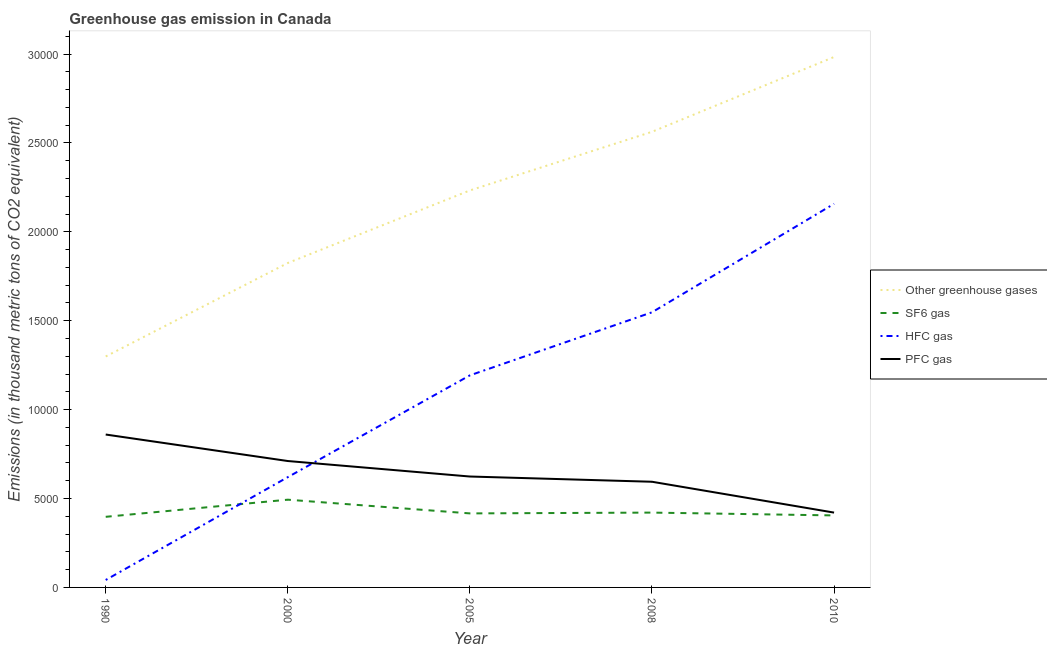What is the emission of greenhouse gases in 2008?
Give a very brief answer. 2.56e+04. Across all years, what is the maximum emission of greenhouse gases?
Give a very brief answer. 2.98e+04. Across all years, what is the minimum emission of hfc gas?
Your response must be concise. 418.5. What is the total emission of hfc gas in the graph?
Offer a very short reply. 5.56e+04. What is the difference between the emission of hfc gas in 1990 and that in 2005?
Make the answer very short. -1.15e+04. What is the difference between the emission of greenhouse gases in 2000 and the emission of sf6 gas in 2008?
Make the answer very short. 1.40e+04. What is the average emission of pfc gas per year?
Your response must be concise. 6420.18. In the year 1990, what is the difference between the emission of pfc gas and emission of sf6 gas?
Provide a short and direct response. 4628.5. What is the ratio of the emission of pfc gas in 1990 to that in 2005?
Offer a very short reply. 1.38. What is the difference between the highest and the second highest emission of sf6 gas?
Ensure brevity in your answer.  726.3. What is the difference between the highest and the lowest emission of sf6 gas?
Offer a terse response. 963.3. In how many years, is the emission of pfc gas greater than the average emission of pfc gas taken over all years?
Provide a succinct answer. 2. Is the sum of the emission of hfc gas in 2008 and 2010 greater than the maximum emission of greenhouse gases across all years?
Keep it short and to the point. Yes. Is it the case that in every year, the sum of the emission of pfc gas and emission of sf6 gas is greater than the sum of emission of hfc gas and emission of greenhouse gases?
Your answer should be very brief. Yes. Does the emission of hfc gas monotonically increase over the years?
Offer a very short reply. Yes. Is the emission of hfc gas strictly greater than the emission of sf6 gas over the years?
Ensure brevity in your answer.  No. Is the emission of pfc gas strictly less than the emission of hfc gas over the years?
Keep it short and to the point. No. How many lines are there?
Keep it short and to the point. 4. What is the difference between two consecutive major ticks on the Y-axis?
Your answer should be very brief. 5000. Are the values on the major ticks of Y-axis written in scientific E-notation?
Your answer should be very brief. No. Does the graph contain grids?
Give a very brief answer. No. Where does the legend appear in the graph?
Provide a short and direct response. Center right. What is the title of the graph?
Provide a succinct answer. Greenhouse gas emission in Canada. Does "Tracking ability" appear as one of the legend labels in the graph?
Your answer should be very brief. No. What is the label or title of the Y-axis?
Ensure brevity in your answer.  Emissions (in thousand metric tons of CO2 equivalent). What is the Emissions (in thousand metric tons of CO2 equivalent) of Other greenhouse gases in 1990?
Keep it short and to the point. 1.30e+04. What is the Emissions (in thousand metric tons of CO2 equivalent) of SF6 gas in 1990?
Give a very brief answer. 3971.8. What is the Emissions (in thousand metric tons of CO2 equivalent) of HFC gas in 1990?
Make the answer very short. 418.5. What is the Emissions (in thousand metric tons of CO2 equivalent) of PFC gas in 1990?
Ensure brevity in your answer.  8600.3. What is the Emissions (in thousand metric tons of CO2 equivalent) of Other greenhouse gases in 2000?
Make the answer very short. 1.82e+04. What is the Emissions (in thousand metric tons of CO2 equivalent) in SF6 gas in 2000?
Ensure brevity in your answer.  4935.1. What is the Emissions (in thousand metric tons of CO2 equivalent) in HFC gas in 2000?
Give a very brief answer. 6202.8. What is the Emissions (in thousand metric tons of CO2 equivalent) in PFC gas in 2000?
Offer a terse response. 7109.9. What is the Emissions (in thousand metric tons of CO2 equivalent) in Other greenhouse gases in 2005?
Keep it short and to the point. 2.23e+04. What is the Emissions (in thousand metric tons of CO2 equivalent) in SF6 gas in 2005?
Provide a short and direct response. 4163.8. What is the Emissions (in thousand metric tons of CO2 equivalent) of HFC gas in 2005?
Give a very brief answer. 1.19e+04. What is the Emissions (in thousand metric tons of CO2 equivalent) in PFC gas in 2005?
Ensure brevity in your answer.  6238. What is the Emissions (in thousand metric tons of CO2 equivalent) in Other greenhouse gases in 2008?
Offer a terse response. 2.56e+04. What is the Emissions (in thousand metric tons of CO2 equivalent) in SF6 gas in 2008?
Your answer should be very brief. 4208.8. What is the Emissions (in thousand metric tons of CO2 equivalent) of HFC gas in 2008?
Give a very brief answer. 1.55e+04. What is the Emissions (in thousand metric tons of CO2 equivalent) of PFC gas in 2008?
Offer a very short reply. 5943.7. What is the Emissions (in thousand metric tons of CO2 equivalent) in Other greenhouse gases in 2010?
Ensure brevity in your answer.  2.98e+04. What is the Emissions (in thousand metric tons of CO2 equivalent) in SF6 gas in 2010?
Give a very brief answer. 4050. What is the Emissions (in thousand metric tons of CO2 equivalent) in HFC gas in 2010?
Give a very brief answer. 2.16e+04. What is the Emissions (in thousand metric tons of CO2 equivalent) in PFC gas in 2010?
Your answer should be compact. 4209. Across all years, what is the maximum Emissions (in thousand metric tons of CO2 equivalent) in Other greenhouse gases?
Your response must be concise. 2.98e+04. Across all years, what is the maximum Emissions (in thousand metric tons of CO2 equivalent) of SF6 gas?
Offer a very short reply. 4935.1. Across all years, what is the maximum Emissions (in thousand metric tons of CO2 equivalent) in HFC gas?
Ensure brevity in your answer.  2.16e+04. Across all years, what is the maximum Emissions (in thousand metric tons of CO2 equivalent) in PFC gas?
Offer a very short reply. 8600.3. Across all years, what is the minimum Emissions (in thousand metric tons of CO2 equivalent) in Other greenhouse gases?
Provide a succinct answer. 1.30e+04. Across all years, what is the minimum Emissions (in thousand metric tons of CO2 equivalent) in SF6 gas?
Give a very brief answer. 3971.8. Across all years, what is the minimum Emissions (in thousand metric tons of CO2 equivalent) of HFC gas?
Make the answer very short. 418.5. Across all years, what is the minimum Emissions (in thousand metric tons of CO2 equivalent) of PFC gas?
Your answer should be compact. 4209. What is the total Emissions (in thousand metric tons of CO2 equivalent) of Other greenhouse gases in the graph?
Offer a very short reply. 1.09e+05. What is the total Emissions (in thousand metric tons of CO2 equivalent) in SF6 gas in the graph?
Make the answer very short. 2.13e+04. What is the total Emissions (in thousand metric tons of CO2 equivalent) in HFC gas in the graph?
Make the answer very short. 5.56e+04. What is the total Emissions (in thousand metric tons of CO2 equivalent) of PFC gas in the graph?
Your response must be concise. 3.21e+04. What is the difference between the Emissions (in thousand metric tons of CO2 equivalent) of Other greenhouse gases in 1990 and that in 2000?
Provide a succinct answer. -5257.2. What is the difference between the Emissions (in thousand metric tons of CO2 equivalent) of SF6 gas in 1990 and that in 2000?
Your answer should be compact. -963.3. What is the difference between the Emissions (in thousand metric tons of CO2 equivalent) of HFC gas in 1990 and that in 2000?
Your answer should be compact. -5784.3. What is the difference between the Emissions (in thousand metric tons of CO2 equivalent) of PFC gas in 1990 and that in 2000?
Your answer should be very brief. 1490.4. What is the difference between the Emissions (in thousand metric tons of CO2 equivalent) in Other greenhouse gases in 1990 and that in 2005?
Provide a succinct answer. -9339.6. What is the difference between the Emissions (in thousand metric tons of CO2 equivalent) in SF6 gas in 1990 and that in 2005?
Offer a very short reply. -192. What is the difference between the Emissions (in thousand metric tons of CO2 equivalent) in HFC gas in 1990 and that in 2005?
Keep it short and to the point. -1.15e+04. What is the difference between the Emissions (in thousand metric tons of CO2 equivalent) in PFC gas in 1990 and that in 2005?
Offer a terse response. 2362.3. What is the difference between the Emissions (in thousand metric tons of CO2 equivalent) in Other greenhouse gases in 1990 and that in 2008?
Offer a terse response. -1.26e+04. What is the difference between the Emissions (in thousand metric tons of CO2 equivalent) in SF6 gas in 1990 and that in 2008?
Make the answer very short. -237. What is the difference between the Emissions (in thousand metric tons of CO2 equivalent) in HFC gas in 1990 and that in 2008?
Give a very brief answer. -1.51e+04. What is the difference between the Emissions (in thousand metric tons of CO2 equivalent) of PFC gas in 1990 and that in 2008?
Your answer should be very brief. 2656.6. What is the difference between the Emissions (in thousand metric tons of CO2 equivalent) in Other greenhouse gases in 1990 and that in 2010?
Provide a short and direct response. -1.68e+04. What is the difference between the Emissions (in thousand metric tons of CO2 equivalent) of SF6 gas in 1990 and that in 2010?
Provide a succinct answer. -78.2. What is the difference between the Emissions (in thousand metric tons of CO2 equivalent) in HFC gas in 1990 and that in 2010?
Offer a terse response. -2.12e+04. What is the difference between the Emissions (in thousand metric tons of CO2 equivalent) of PFC gas in 1990 and that in 2010?
Your answer should be very brief. 4391.3. What is the difference between the Emissions (in thousand metric tons of CO2 equivalent) of Other greenhouse gases in 2000 and that in 2005?
Keep it short and to the point. -4082.4. What is the difference between the Emissions (in thousand metric tons of CO2 equivalent) of SF6 gas in 2000 and that in 2005?
Keep it short and to the point. 771.3. What is the difference between the Emissions (in thousand metric tons of CO2 equivalent) of HFC gas in 2000 and that in 2005?
Ensure brevity in your answer.  -5725.6. What is the difference between the Emissions (in thousand metric tons of CO2 equivalent) of PFC gas in 2000 and that in 2005?
Provide a short and direct response. 871.9. What is the difference between the Emissions (in thousand metric tons of CO2 equivalent) in Other greenhouse gases in 2000 and that in 2008?
Offer a terse response. -7379.5. What is the difference between the Emissions (in thousand metric tons of CO2 equivalent) of SF6 gas in 2000 and that in 2008?
Offer a terse response. 726.3. What is the difference between the Emissions (in thousand metric tons of CO2 equivalent) of HFC gas in 2000 and that in 2008?
Keep it short and to the point. -9272. What is the difference between the Emissions (in thousand metric tons of CO2 equivalent) in PFC gas in 2000 and that in 2008?
Offer a terse response. 1166.2. What is the difference between the Emissions (in thousand metric tons of CO2 equivalent) in Other greenhouse gases in 2000 and that in 2010?
Your answer should be very brief. -1.16e+04. What is the difference between the Emissions (in thousand metric tons of CO2 equivalent) in SF6 gas in 2000 and that in 2010?
Ensure brevity in your answer.  885.1. What is the difference between the Emissions (in thousand metric tons of CO2 equivalent) of HFC gas in 2000 and that in 2010?
Provide a short and direct response. -1.54e+04. What is the difference between the Emissions (in thousand metric tons of CO2 equivalent) of PFC gas in 2000 and that in 2010?
Your response must be concise. 2900.9. What is the difference between the Emissions (in thousand metric tons of CO2 equivalent) of Other greenhouse gases in 2005 and that in 2008?
Provide a short and direct response. -3297.1. What is the difference between the Emissions (in thousand metric tons of CO2 equivalent) in SF6 gas in 2005 and that in 2008?
Your answer should be very brief. -45. What is the difference between the Emissions (in thousand metric tons of CO2 equivalent) in HFC gas in 2005 and that in 2008?
Offer a terse response. -3546.4. What is the difference between the Emissions (in thousand metric tons of CO2 equivalent) of PFC gas in 2005 and that in 2008?
Provide a succinct answer. 294.3. What is the difference between the Emissions (in thousand metric tons of CO2 equivalent) of Other greenhouse gases in 2005 and that in 2010?
Give a very brief answer. -7505.8. What is the difference between the Emissions (in thousand metric tons of CO2 equivalent) in SF6 gas in 2005 and that in 2010?
Your answer should be very brief. 113.8. What is the difference between the Emissions (in thousand metric tons of CO2 equivalent) of HFC gas in 2005 and that in 2010?
Make the answer very short. -9648.6. What is the difference between the Emissions (in thousand metric tons of CO2 equivalent) in PFC gas in 2005 and that in 2010?
Make the answer very short. 2029. What is the difference between the Emissions (in thousand metric tons of CO2 equivalent) in Other greenhouse gases in 2008 and that in 2010?
Your answer should be very brief. -4208.7. What is the difference between the Emissions (in thousand metric tons of CO2 equivalent) in SF6 gas in 2008 and that in 2010?
Offer a terse response. 158.8. What is the difference between the Emissions (in thousand metric tons of CO2 equivalent) of HFC gas in 2008 and that in 2010?
Make the answer very short. -6102.2. What is the difference between the Emissions (in thousand metric tons of CO2 equivalent) of PFC gas in 2008 and that in 2010?
Give a very brief answer. 1734.7. What is the difference between the Emissions (in thousand metric tons of CO2 equivalent) in Other greenhouse gases in 1990 and the Emissions (in thousand metric tons of CO2 equivalent) in SF6 gas in 2000?
Your answer should be compact. 8055.5. What is the difference between the Emissions (in thousand metric tons of CO2 equivalent) in Other greenhouse gases in 1990 and the Emissions (in thousand metric tons of CO2 equivalent) in HFC gas in 2000?
Provide a short and direct response. 6787.8. What is the difference between the Emissions (in thousand metric tons of CO2 equivalent) of Other greenhouse gases in 1990 and the Emissions (in thousand metric tons of CO2 equivalent) of PFC gas in 2000?
Keep it short and to the point. 5880.7. What is the difference between the Emissions (in thousand metric tons of CO2 equivalent) of SF6 gas in 1990 and the Emissions (in thousand metric tons of CO2 equivalent) of HFC gas in 2000?
Your response must be concise. -2231. What is the difference between the Emissions (in thousand metric tons of CO2 equivalent) in SF6 gas in 1990 and the Emissions (in thousand metric tons of CO2 equivalent) in PFC gas in 2000?
Provide a succinct answer. -3138.1. What is the difference between the Emissions (in thousand metric tons of CO2 equivalent) of HFC gas in 1990 and the Emissions (in thousand metric tons of CO2 equivalent) of PFC gas in 2000?
Keep it short and to the point. -6691.4. What is the difference between the Emissions (in thousand metric tons of CO2 equivalent) of Other greenhouse gases in 1990 and the Emissions (in thousand metric tons of CO2 equivalent) of SF6 gas in 2005?
Provide a succinct answer. 8826.8. What is the difference between the Emissions (in thousand metric tons of CO2 equivalent) in Other greenhouse gases in 1990 and the Emissions (in thousand metric tons of CO2 equivalent) in HFC gas in 2005?
Offer a very short reply. 1062.2. What is the difference between the Emissions (in thousand metric tons of CO2 equivalent) in Other greenhouse gases in 1990 and the Emissions (in thousand metric tons of CO2 equivalent) in PFC gas in 2005?
Offer a very short reply. 6752.6. What is the difference between the Emissions (in thousand metric tons of CO2 equivalent) of SF6 gas in 1990 and the Emissions (in thousand metric tons of CO2 equivalent) of HFC gas in 2005?
Provide a succinct answer. -7956.6. What is the difference between the Emissions (in thousand metric tons of CO2 equivalent) in SF6 gas in 1990 and the Emissions (in thousand metric tons of CO2 equivalent) in PFC gas in 2005?
Make the answer very short. -2266.2. What is the difference between the Emissions (in thousand metric tons of CO2 equivalent) in HFC gas in 1990 and the Emissions (in thousand metric tons of CO2 equivalent) in PFC gas in 2005?
Provide a short and direct response. -5819.5. What is the difference between the Emissions (in thousand metric tons of CO2 equivalent) of Other greenhouse gases in 1990 and the Emissions (in thousand metric tons of CO2 equivalent) of SF6 gas in 2008?
Offer a terse response. 8781.8. What is the difference between the Emissions (in thousand metric tons of CO2 equivalent) in Other greenhouse gases in 1990 and the Emissions (in thousand metric tons of CO2 equivalent) in HFC gas in 2008?
Offer a terse response. -2484.2. What is the difference between the Emissions (in thousand metric tons of CO2 equivalent) in Other greenhouse gases in 1990 and the Emissions (in thousand metric tons of CO2 equivalent) in PFC gas in 2008?
Your answer should be compact. 7046.9. What is the difference between the Emissions (in thousand metric tons of CO2 equivalent) of SF6 gas in 1990 and the Emissions (in thousand metric tons of CO2 equivalent) of HFC gas in 2008?
Provide a short and direct response. -1.15e+04. What is the difference between the Emissions (in thousand metric tons of CO2 equivalent) of SF6 gas in 1990 and the Emissions (in thousand metric tons of CO2 equivalent) of PFC gas in 2008?
Provide a succinct answer. -1971.9. What is the difference between the Emissions (in thousand metric tons of CO2 equivalent) of HFC gas in 1990 and the Emissions (in thousand metric tons of CO2 equivalent) of PFC gas in 2008?
Give a very brief answer. -5525.2. What is the difference between the Emissions (in thousand metric tons of CO2 equivalent) in Other greenhouse gases in 1990 and the Emissions (in thousand metric tons of CO2 equivalent) in SF6 gas in 2010?
Give a very brief answer. 8940.6. What is the difference between the Emissions (in thousand metric tons of CO2 equivalent) in Other greenhouse gases in 1990 and the Emissions (in thousand metric tons of CO2 equivalent) in HFC gas in 2010?
Your answer should be very brief. -8586.4. What is the difference between the Emissions (in thousand metric tons of CO2 equivalent) in Other greenhouse gases in 1990 and the Emissions (in thousand metric tons of CO2 equivalent) in PFC gas in 2010?
Your answer should be very brief. 8781.6. What is the difference between the Emissions (in thousand metric tons of CO2 equivalent) in SF6 gas in 1990 and the Emissions (in thousand metric tons of CO2 equivalent) in HFC gas in 2010?
Your answer should be compact. -1.76e+04. What is the difference between the Emissions (in thousand metric tons of CO2 equivalent) of SF6 gas in 1990 and the Emissions (in thousand metric tons of CO2 equivalent) of PFC gas in 2010?
Offer a terse response. -237.2. What is the difference between the Emissions (in thousand metric tons of CO2 equivalent) of HFC gas in 1990 and the Emissions (in thousand metric tons of CO2 equivalent) of PFC gas in 2010?
Provide a short and direct response. -3790.5. What is the difference between the Emissions (in thousand metric tons of CO2 equivalent) of Other greenhouse gases in 2000 and the Emissions (in thousand metric tons of CO2 equivalent) of SF6 gas in 2005?
Offer a terse response. 1.41e+04. What is the difference between the Emissions (in thousand metric tons of CO2 equivalent) in Other greenhouse gases in 2000 and the Emissions (in thousand metric tons of CO2 equivalent) in HFC gas in 2005?
Ensure brevity in your answer.  6319.4. What is the difference between the Emissions (in thousand metric tons of CO2 equivalent) in Other greenhouse gases in 2000 and the Emissions (in thousand metric tons of CO2 equivalent) in PFC gas in 2005?
Your response must be concise. 1.20e+04. What is the difference between the Emissions (in thousand metric tons of CO2 equivalent) in SF6 gas in 2000 and the Emissions (in thousand metric tons of CO2 equivalent) in HFC gas in 2005?
Make the answer very short. -6993.3. What is the difference between the Emissions (in thousand metric tons of CO2 equivalent) in SF6 gas in 2000 and the Emissions (in thousand metric tons of CO2 equivalent) in PFC gas in 2005?
Your answer should be compact. -1302.9. What is the difference between the Emissions (in thousand metric tons of CO2 equivalent) of HFC gas in 2000 and the Emissions (in thousand metric tons of CO2 equivalent) of PFC gas in 2005?
Give a very brief answer. -35.2. What is the difference between the Emissions (in thousand metric tons of CO2 equivalent) of Other greenhouse gases in 2000 and the Emissions (in thousand metric tons of CO2 equivalent) of SF6 gas in 2008?
Make the answer very short. 1.40e+04. What is the difference between the Emissions (in thousand metric tons of CO2 equivalent) in Other greenhouse gases in 2000 and the Emissions (in thousand metric tons of CO2 equivalent) in HFC gas in 2008?
Your answer should be very brief. 2773. What is the difference between the Emissions (in thousand metric tons of CO2 equivalent) of Other greenhouse gases in 2000 and the Emissions (in thousand metric tons of CO2 equivalent) of PFC gas in 2008?
Make the answer very short. 1.23e+04. What is the difference between the Emissions (in thousand metric tons of CO2 equivalent) in SF6 gas in 2000 and the Emissions (in thousand metric tons of CO2 equivalent) in HFC gas in 2008?
Give a very brief answer. -1.05e+04. What is the difference between the Emissions (in thousand metric tons of CO2 equivalent) of SF6 gas in 2000 and the Emissions (in thousand metric tons of CO2 equivalent) of PFC gas in 2008?
Offer a terse response. -1008.6. What is the difference between the Emissions (in thousand metric tons of CO2 equivalent) in HFC gas in 2000 and the Emissions (in thousand metric tons of CO2 equivalent) in PFC gas in 2008?
Offer a terse response. 259.1. What is the difference between the Emissions (in thousand metric tons of CO2 equivalent) of Other greenhouse gases in 2000 and the Emissions (in thousand metric tons of CO2 equivalent) of SF6 gas in 2010?
Offer a very short reply. 1.42e+04. What is the difference between the Emissions (in thousand metric tons of CO2 equivalent) of Other greenhouse gases in 2000 and the Emissions (in thousand metric tons of CO2 equivalent) of HFC gas in 2010?
Ensure brevity in your answer.  -3329.2. What is the difference between the Emissions (in thousand metric tons of CO2 equivalent) in Other greenhouse gases in 2000 and the Emissions (in thousand metric tons of CO2 equivalent) in PFC gas in 2010?
Your answer should be compact. 1.40e+04. What is the difference between the Emissions (in thousand metric tons of CO2 equivalent) of SF6 gas in 2000 and the Emissions (in thousand metric tons of CO2 equivalent) of HFC gas in 2010?
Offer a terse response. -1.66e+04. What is the difference between the Emissions (in thousand metric tons of CO2 equivalent) in SF6 gas in 2000 and the Emissions (in thousand metric tons of CO2 equivalent) in PFC gas in 2010?
Provide a short and direct response. 726.1. What is the difference between the Emissions (in thousand metric tons of CO2 equivalent) of HFC gas in 2000 and the Emissions (in thousand metric tons of CO2 equivalent) of PFC gas in 2010?
Give a very brief answer. 1993.8. What is the difference between the Emissions (in thousand metric tons of CO2 equivalent) of Other greenhouse gases in 2005 and the Emissions (in thousand metric tons of CO2 equivalent) of SF6 gas in 2008?
Your answer should be very brief. 1.81e+04. What is the difference between the Emissions (in thousand metric tons of CO2 equivalent) in Other greenhouse gases in 2005 and the Emissions (in thousand metric tons of CO2 equivalent) in HFC gas in 2008?
Ensure brevity in your answer.  6855.4. What is the difference between the Emissions (in thousand metric tons of CO2 equivalent) in Other greenhouse gases in 2005 and the Emissions (in thousand metric tons of CO2 equivalent) in PFC gas in 2008?
Your answer should be compact. 1.64e+04. What is the difference between the Emissions (in thousand metric tons of CO2 equivalent) of SF6 gas in 2005 and the Emissions (in thousand metric tons of CO2 equivalent) of HFC gas in 2008?
Make the answer very short. -1.13e+04. What is the difference between the Emissions (in thousand metric tons of CO2 equivalent) of SF6 gas in 2005 and the Emissions (in thousand metric tons of CO2 equivalent) of PFC gas in 2008?
Your answer should be compact. -1779.9. What is the difference between the Emissions (in thousand metric tons of CO2 equivalent) of HFC gas in 2005 and the Emissions (in thousand metric tons of CO2 equivalent) of PFC gas in 2008?
Your response must be concise. 5984.7. What is the difference between the Emissions (in thousand metric tons of CO2 equivalent) of Other greenhouse gases in 2005 and the Emissions (in thousand metric tons of CO2 equivalent) of SF6 gas in 2010?
Offer a very short reply. 1.83e+04. What is the difference between the Emissions (in thousand metric tons of CO2 equivalent) of Other greenhouse gases in 2005 and the Emissions (in thousand metric tons of CO2 equivalent) of HFC gas in 2010?
Keep it short and to the point. 753.2. What is the difference between the Emissions (in thousand metric tons of CO2 equivalent) in Other greenhouse gases in 2005 and the Emissions (in thousand metric tons of CO2 equivalent) in PFC gas in 2010?
Offer a very short reply. 1.81e+04. What is the difference between the Emissions (in thousand metric tons of CO2 equivalent) in SF6 gas in 2005 and the Emissions (in thousand metric tons of CO2 equivalent) in HFC gas in 2010?
Offer a terse response. -1.74e+04. What is the difference between the Emissions (in thousand metric tons of CO2 equivalent) of SF6 gas in 2005 and the Emissions (in thousand metric tons of CO2 equivalent) of PFC gas in 2010?
Your answer should be very brief. -45.2. What is the difference between the Emissions (in thousand metric tons of CO2 equivalent) in HFC gas in 2005 and the Emissions (in thousand metric tons of CO2 equivalent) in PFC gas in 2010?
Your answer should be very brief. 7719.4. What is the difference between the Emissions (in thousand metric tons of CO2 equivalent) in Other greenhouse gases in 2008 and the Emissions (in thousand metric tons of CO2 equivalent) in SF6 gas in 2010?
Ensure brevity in your answer.  2.16e+04. What is the difference between the Emissions (in thousand metric tons of CO2 equivalent) in Other greenhouse gases in 2008 and the Emissions (in thousand metric tons of CO2 equivalent) in HFC gas in 2010?
Provide a short and direct response. 4050.3. What is the difference between the Emissions (in thousand metric tons of CO2 equivalent) in Other greenhouse gases in 2008 and the Emissions (in thousand metric tons of CO2 equivalent) in PFC gas in 2010?
Ensure brevity in your answer.  2.14e+04. What is the difference between the Emissions (in thousand metric tons of CO2 equivalent) in SF6 gas in 2008 and the Emissions (in thousand metric tons of CO2 equivalent) in HFC gas in 2010?
Make the answer very short. -1.74e+04. What is the difference between the Emissions (in thousand metric tons of CO2 equivalent) of SF6 gas in 2008 and the Emissions (in thousand metric tons of CO2 equivalent) of PFC gas in 2010?
Provide a short and direct response. -0.2. What is the difference between the Emissions (in thousand metric tons of CO2 equivalent) of HFC gas in 2008 and the Emissions (in thousand metric tons of CO2 equivalent) of PFC gas in 2010?
Ensure brevity in your answer.  1.13e+04. What is the average Emissions (in thousand metric tons of CO2 equivalent) in Other greenhouse gases per year?
Provide a short and direct response. 2.18e+04. What is the average Emissions (in thousand metric tons of CO2 equivalent) of SF6 gas per year?
Offer a very short reply. 4265.9. What is the average Emissions (in thousand metric tons of CO2 equivalent) in HFC gas per year?
Give a very brief answer. 1.11e+04. What is the average Emissions (in thousand metric tons of CO2 equivalent) in PFC gas per year?
Make the answer very short. 6420.18. In the year 1990, what is the difference between the Emissions (in thousand metric tons of CO2 equivalent) in Other greenhouse gases and Emissions (in thousand metric tons of CO2 equivalent) in SF6 gas?
Offer a terse response. 9018.8. In the year 1990, what is the difference between the Emissions (in thousand metric tons of CO2 equivalent) in Other greenhouse gases and Emissions (in thousand metric tons of CO2 equivalent) in HFC gas?
Provide a succinct answer. 1.26e+04. In the year 1990, what is the difference between the Emissions (in thousand metric tons of CO2 equivalent) of Other greenhouse gases and Emissions (in thousand metric tons of CO2 equivalent) of PFC gas?
Offer a very short reply. 4390.3. In the year 1990, what is the difference between the Emissions (in thousand metric tons of CO2 equivalent) of SF6 gas and Emissions (in thousand metric tons of CO2 equivalent) of HFC gas?
Give a very brief answer. 3553.3. In the year 1990, what is the difference between the Emissions (in thousand metric tons of CO2 equivalent) of SF6 gas and Emissions (in thousand metric tons of CO2 equivalent) of PFC gas?
Your answer should be very brief. -4628.5. In the year 1990, what is the difference between the Emissions (in thousand metric tons of CO2 equivalent) of HFC gas and Emissions (in thousand metric tons of CO2 equivalent) of PFC gas?
Give a very brief answer. -8181.8. In the year 2000, what is the difference between the Emissions (in thousand metric tons of CO2 equivalent) of Other greenhouse gases and Emissions (in thousand metric tons of CO2 equivalent) of SF6 gas?
Offer a terse response. 1.33e+04. In the year 2000, what is the difference between the Emissions (in thousand metric tons of CO2 equivalent) in Other greenhouse gases and Emissions (in thousand metric tons of CO2 equivalent) in HFC gas?
Offer a terse response. 1.20e+04. In the year 2000, what is the difference between the Emissions (in thousand metric tons of CO2 equivalent) of Other greenhouse gases and Emissions (in thousand metric tons of CO2 equivalent) of PFC gas?
Your response must be concise. 1.11e+04. In the year 2000, what is the difference between the Emissions (in thousand metric tons of CO2 equivalent) in SF6 gas and Emissions (in thousand metric tons of CO2 equivalent) in HFC gas?
Keep it short and to the point. -1267.7. In the year 2000, what is the difference between the Emissions (in thousand metric tons of CO2 equivalent) of SF6 gas and Emissions (in thousand metric tons of CO2 equivalent) of PFC gas?
Offer a terse response. -2174.8. In the year 2000, what is the difference between the Emissions (in thousand metric tons of CO2 equivalent) of HFC gas and Emissions (in thousand metric tons of CO2 equivalent) of PFC gas?
Provide a succinct answer. -907.1. In the year 2005, what is the difference between the Emissions (in thousand metric tons of CO2 equivalent) of Other greenhouse gases and Emissions (in thousand metric tons of CO2 equivalent) of SF6 gas?
Keep it short and to the point. 1.82e+04. In the year 2005, what is the difference between the Emissions (in thousand metric tons of CO2 equivalent) in Other greenhouse gases and Emissions (in thousand metric tons of CO2 equivalent) in HFC gas?
Your response must be concise. 1.04e+04. In the year 2005, what is the difference between the Emissions (in thousand metric tons of CO2 equivalent) of Other greenhouse gases and Emissions (in thousand metric tons of CO2 equivalent) of PFC gas?
Offer a terse response. 1.61e+04. In the year 2005, what is the difference between the Emissions (in thousand metric tons of CO2 equivalent) in SF6 gas and Emissions (in thousand metric tons of CO2 equivalent) in HFC gas?
Make the answer very short. -7764.6. In the year 2005, what is the difference between the Emissions (in thousand metric tons of CO2 equivalent) of SF6 gas and Emissions (in thousand metric tons of CO2 equivalent) of PFC gas?
Your answer should be very brief. -2074.2. In the year 2005, what is the difference between the Emissions (in thousand metric tons of CO2 equivalent) of HFC gas and Emissions (in thousand metric tons of CO2 equivalent) of PFC gas?
Provide a short and direct response. 5690.4. In the year 2008, what is the difference between the Emissions (in thousand metric tons of CO2 equivalent) in Other greenhouse gases and Emissions (in thousand metric tons of CO2 equivalent) in SF6 gas?
Provide a succinct answer. 2.14e+04. In the year 2008, what is the difference between the Emissions (in thousand metric tons of CO2 equivalent) in Other greenhouse gases and Emissions (in thousand metric tons of CO2 equivalent) in HFC gas?
Keep it short and to the point. 1.02e+04. In the year 2008, what is the difference between the Emissions (in thousand metric tons of CO2 equivalent) of Other greenhouse gases and Emissions (in thousand metric tons of CO2 equivalent) of PFC gas?
Provide a short and direct response. 1.97e+04. In the year 2008, what is the difference between the Emissions (in thousand metric tons of CO2 equivalent) in SF6 gas and Emissions (in thousand metric tons of CO2 equivalent) in HFC gas?
Your response must be concise. -1.13e+04. In the year 2008, what is the difference between the Emissions (in thousand metric tons of CO2 equivalent) of SF6 gas and Emissions (in thousand metric tons of CO2 equivalent) of PFC gas?
Provide a short and direct response. -1734.9. In the year 2008, what is the difference between the Emissions (in thousand metric tons of CO2 equivalent) of HFC gas and Emissions (in thousand metric tons of CO2 equivalent) of PFC gas?
Provide a succinct answer. 9531.1. In the year 2010, what is the difference between the Emissions (in thousand metric tons of CO2 equivalent) in Other greenhouse gases and Emissions (in thousand metric tons of CO2 equivalent) in SF6 gas?
Your response must be concise. 2.58e+04. In the year 2010, what is the difference between the Emissions (in thousand metric tons of CO2 equivalent) in Other greenhouse gases and Emissions (in thousand metric tons of CO2 equivalent) in HFC gas?
Offer a terse response. 8259. In the year 2010, what is the difference between the Emissions (in thousand metric tons of CO2 equivalent) of Other greenhouse gases and Emissions (in thousand metric tons of CO2 equivalent) of PFC gas?
Your answer should be compact. 2.56e+04. In the year 2010, what is the difference between the Emissions (in thousand metric tons of CO2 equivalent) in SF6 gas and Emissions (in thousand metric tons of CO2 equivalent) in HFC gas?
Your answer should be compact. -1.75e+04. In the year 2010, what is the difference between the Emissions (in thousand metric tons of CO2 equivalent) of SF6 gas and Emissions (in thousand metric tons of CO2 equivalent) of PFC gas?
Offer a very short reply. -159. In the year 2010, what is the difference between the Emissions (in thousand metric tons of CO2 equivalent) of HFC gas and Emissions (in thousand metric tons of CO2 equivalent) of PFC gas?
Make the answer very short. 1.74e+04. What is the ratio of the Emissions (in thousand metric tons of CO2 equivalent) of Other greenhouse gases in 1990 to that in 2000?
Ensure brevity in your answer.  0.71. What is the ratio of the Emissions (in thousand metric tons of CO2 equivalent) in SF6 gas in 1990 to that in 2000?
Give a very brief answer. 0.8. What is the ratio of the Emissions (in thousand metric tons of CO2 equivalent) of HFC gas in 1990 to that in 2000?
Offer a terse response. 0.07. What is the ratio of the Emissions (in thousand metric tons of CO2 equivalent) in PFC gas in 1990 to that in 2000?
Give a very brief answer. 1.21. What is the ratio of the Emissions (in thousand metric tons of CO2 equivalent) of Other greenhouse gases in 1990 to that in 2005?
Provide a succinct answer. 0.58. What is the ratio of the Emissions (in thousand metric tons of CO2 equivalent) of SF6 gas in 1990 to that in 2005?
Offer a terse response. 0.95. What is the ratio of the Emissions (in thousand metric tons of CO2 equivalent) of HFC gas in 1990 to that in 2005?
Give a very brief answer. 0.04. What is the ratio of the Emissions (in thousand metric tons of CO2 equivalent) in PFC gas in 1990 to that in 2005?
Provide a succinct answer. 1.38. What is the ratio of the Emissions (in thousand metric tons of CO2 equivalent) of Other greenhouse gases in 1990 to that in 2008?
Ensure brevity in your answer.  0.51. What is the ratio of the Emissions (in thousand metric tons of CO2 equivalent) of SF6 gas in 1990 to that in 2008?
Give a very brief answer. 0.94. What is the ratio of the Emissions (in thousand metric tons of CO2 equivalent) in HFC gas in 1990 to that in 2008?
Provide a short and direct response. 0.03. What is the ratio of the Emissions (in thousand metric tons of CO2 equivalent) in PFC gas in 1990 to that in 2008?
Keep it short and to the point. 1.45. What is the ratio of the Emissions (in thousand metric tons of CO2 equivalent) of Other greenhouse gases in 1990 to that in 2010?
Your response must be concise. 0.44. What is the ratio of the Emissions (in thousand metric tons of CO2 equivalent) in SF6 gas in 1990 to that in 2010?
Your answer should be very brief. 0.98. What is the ratio of the Emissions (in thousand metric tons of CO2 equivalent) in HFC gas in 1990 to that in 2010?
Provide a succinct answer. 0.02. What is the ratio of the Emissions (in thousand metric tons of CO2 equivalent) in PFC gas in 1990 to that in 2010?
Make the answer very short. 2.04. What is the ratio of the Emissions (in thousand metric tons of CO2 equivalent) in Other greenhouse gases in 2000 to that in 2005?
Provide a short and direct response. 0.82. What is the ratio of the Emissions (in thousand metric tons of CO2 equivalent) of SF6 gas in 2000 to that in 2005?
Keep it short and to the point. 1.19. What is the ratio of the Emissions (in thousand metric tons of CO2 equivalent) in HFC gas in 2000 to that in 2005?
Give a very brief answer. 0.52. What is the ratio of the Emissions (in thousand metric tons of CO2 equivalent) of PFC gas in 2000 to that in 2005?
Provide a succinct answer. 1.14. What is the ratio of the Emissions (in thousand metric tons of CO2 equivalent) in Other greenhouse gases in 2000 to that in 2008?
Provide a succinct answer. 0.71. What is the ratio of the Emissions (in thousand metric tons of CO2 equivalent) in SF6 gas in 2000 to that in 2008?
Make the answer very short. 1.17. What is the ratio of the Emissions (in thousand metric tons of CO2 equivalent) in HFC gas in 2000 to that in 2008?
Make the answer very short. 0.4. What is the ratio of the Emissions (in thousand metric tons of CO2 equivalent) in PFC gas in 2000 to that in 2008?
Provide a short and direct response. 1.2. What is the ratio of the Emissions (in thousand metric tons of CO2 equivalent) in Other greenhouse gases in 2000 to that in 2010?
Give a very brief answer. 0.61. What is the ratio of the Emissions (in thousand metric tons of CO2 equivalent) of SF6 gas in 2000 to that in 2010?
Offer a terse response. 1.22. What is the ratio of the Emissions (in thousand metric tons of CO2 equivalent) in HFC gas in 2000 to that in 2010?
Your response must be concise. 0.29. What is the ratio of the Emissions (in thousand metric tons of CO2 equivalent) of PFC gas in 2000 to that in 2010?
Keep it short and to the point. 1.69. What is the ratio of the Emissions (in thousand metric tons of CO2 equivalent) of Other greenhouse gases in 2005 to that in 2008?
Your answer should be very brief. 0.87. What is the ratio of the Emissions (in thousand metric tons of CO2 equivalent) in SF6 gas in 2005 to that in 2008?
Your response must be concise. 0.99. What is the ratio of the Emissions (in thousand metric tons of CO2 equivalent) in HFC gas in 2005 to that in 2008?
Your response must be concise. 0.77. What is the ratio of the Emissions (in thousand metric tons of CO2 equivalent) in PFC gas in 2005 to that in 2008?
Your response must be concise. 1.05. What is the ratio of the Emissions (in thousand metric tons of CO2 equivalent) in Other greenhouse gases in 2005 to that in 2010?
Your response must be concise. 0.75. What is the ratio of the Emissions (in thousand metric tons of CO2 equivalent) of SF6 gas in 2005 to that in 2010?
Your response must be concise. 1.03. What is the ratio of the Emissions (in thousand metric tons of CO2 equivalent) of HFC gas in 2005 to that in 2010?
Provide a short and direct response. 0.55. What is the ratio of the Emissions (in thousand metric tons of CO2 equivalent) in PFC gas in 2005 to that in 2010?
Keep it short and to the point. 1.48. What is the ratio of the Emissions (in thousand metric tons of CO2 equivalent) in Other greenhouse gases in 2008 to that in 2010?
Keep it short and to the point. 0.86. What is the ratio of the Emissions (in thousand metric tons of CO2 equivalent) of SF6 gas in 2008 to that in 2010?
Your response must be concise. 1.04. What is the ratio of the Emissions (in thousand metric tons of CO2 equivalent) in HFC gas in 2008 to that in 2010?
Provide a short and direct response. 0.72. What is the ratio of the Emissions (in thousand metric tons of CO2 equivalent) of PFC gas in 2008 to that in 2010?
Offer a terse response. 1.41. What is the difference between the highest and the second highest Emissions (in thousand metric tons of CO2 equivalent) of Other greenhouse gases?
Offer a terse response. 4208.7. What is the difference between the highest and the second highest Emissions (in thousand metric tons of CO2 equivalent) in SF6 gas?
Keep it short and to the point. 726.3. What is the difference between the highest and the second highest Emissions (in thousand metric tons of CO2 equivalent) in HFC gas?
Make the answer very short. 6102.2. What is the difference between the highest and the second highest Emissions (in thousand metric tons of CO2 equivalent) in PFC gas?
Give a very brief answer. 1490.4. What is the difference between the highest and the lowest Emissions (in thousand metric tons of CO2 equivalent) in Other greenhouse gases?
Give a very brief answer. 1.68e+04. What is the difference between the highest and the lowest Emissions (in thousand metric tons of CO2 equivalent) in SF6 gas?
Give a very brief answer. 963.3. What is the difference between the highest and the lowest Emissions (in thousand metric tons of CO2 equivalent) of HFC gas?
Provide a short and direct response. 2.12e+04. What is the difference between the highest and the lowest Emissions (in thousand metric tons of CO2 equivalent) in PFC gas?
Make the answer very short. 4391.3. 